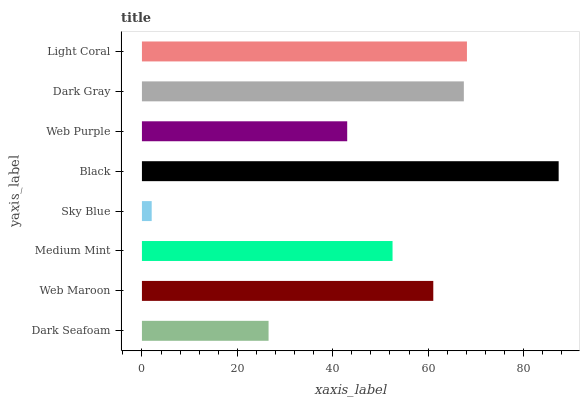Is Sky Blue the minimum?
Answer yes or no. Yes. Is Black the maximum?
Answer yes or no. Yes. Is Web Maroon the minimum?
Answer yes or no. No. Is Web Maroon the maximum?
Answer yes or no. No. Is Web Maroon greater than Dark Seafoam?
Answer yes or no. Yes. Is Dark Seafoam less than Web Maroon?
Answer yes or no. Yes. Is Dark Seafoam greater than Web Maroon?
Answer yes or no. No. Is Web Maroon less than Dark Seafoam?
Answer yes or no. No. Is Web Maroon the high median?
Answer yes or no. Yes. Is Medium Mint the low median?
Answer yes or no. Yes. Is Sky Blue the high median?
Answer yes or no. No. Is Dark Seafoam the low median?
Answer yes or no. No. 